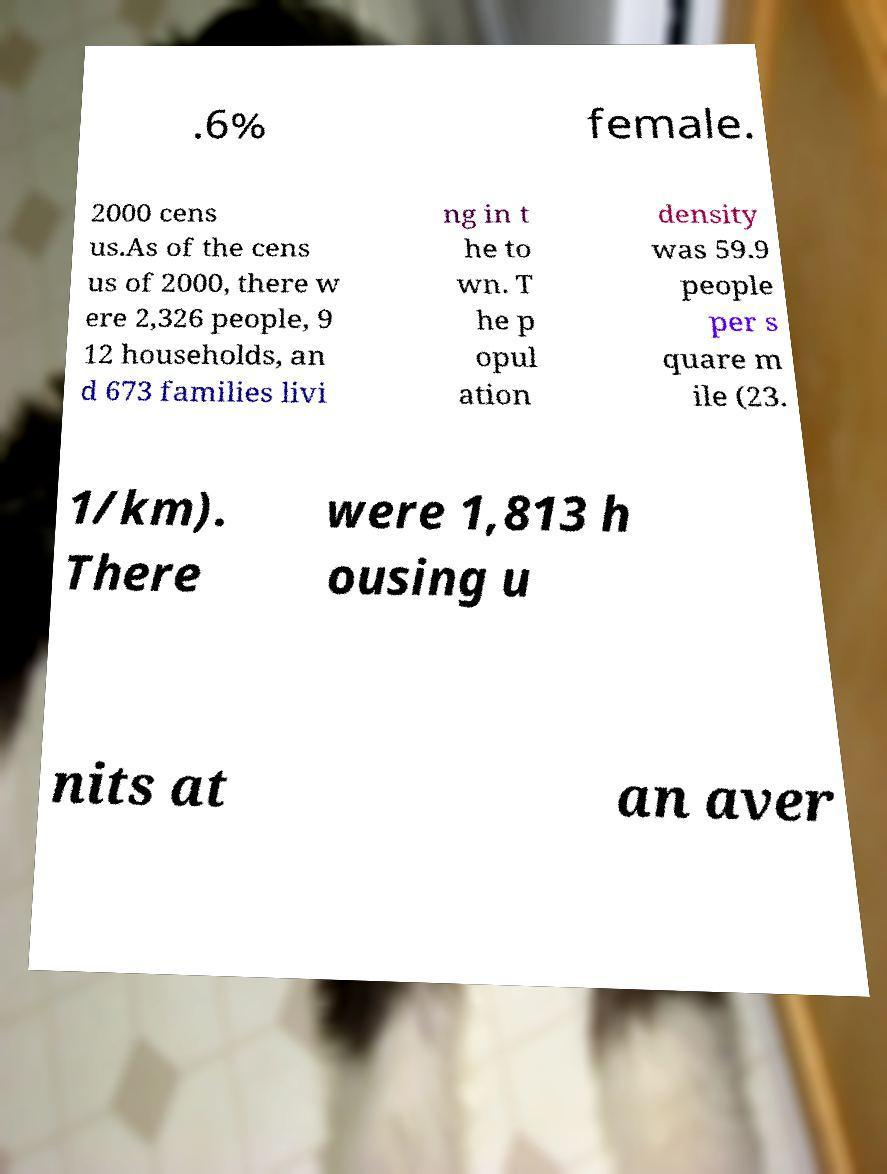Could you assist in decoding the text presented in this image and type it out clearly? .6% female. 2000 cens us.As of the cens us of 2000, there w ere 2,326 people, 9 12 households, an d 673 families livi ng in t he to wn. T he p opul ation density was 59.9 people per s quare m ile (23. 1/km). There were 1,813 h ousing u nits at an aver 